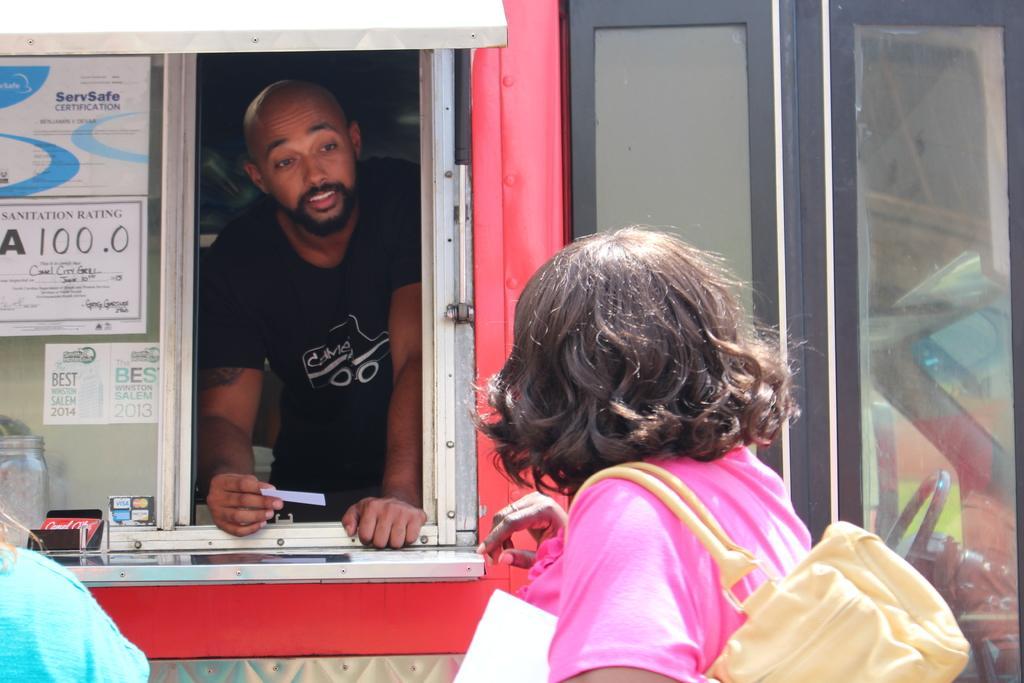In one or two sentences, can you explain what this image depicts? In this image, we can see people and one of them is wearing a bag and holding a paper. In the background, there is a vehicle and we can see some doors and some posters and some other objects and there is a person standing and holding a paper. 